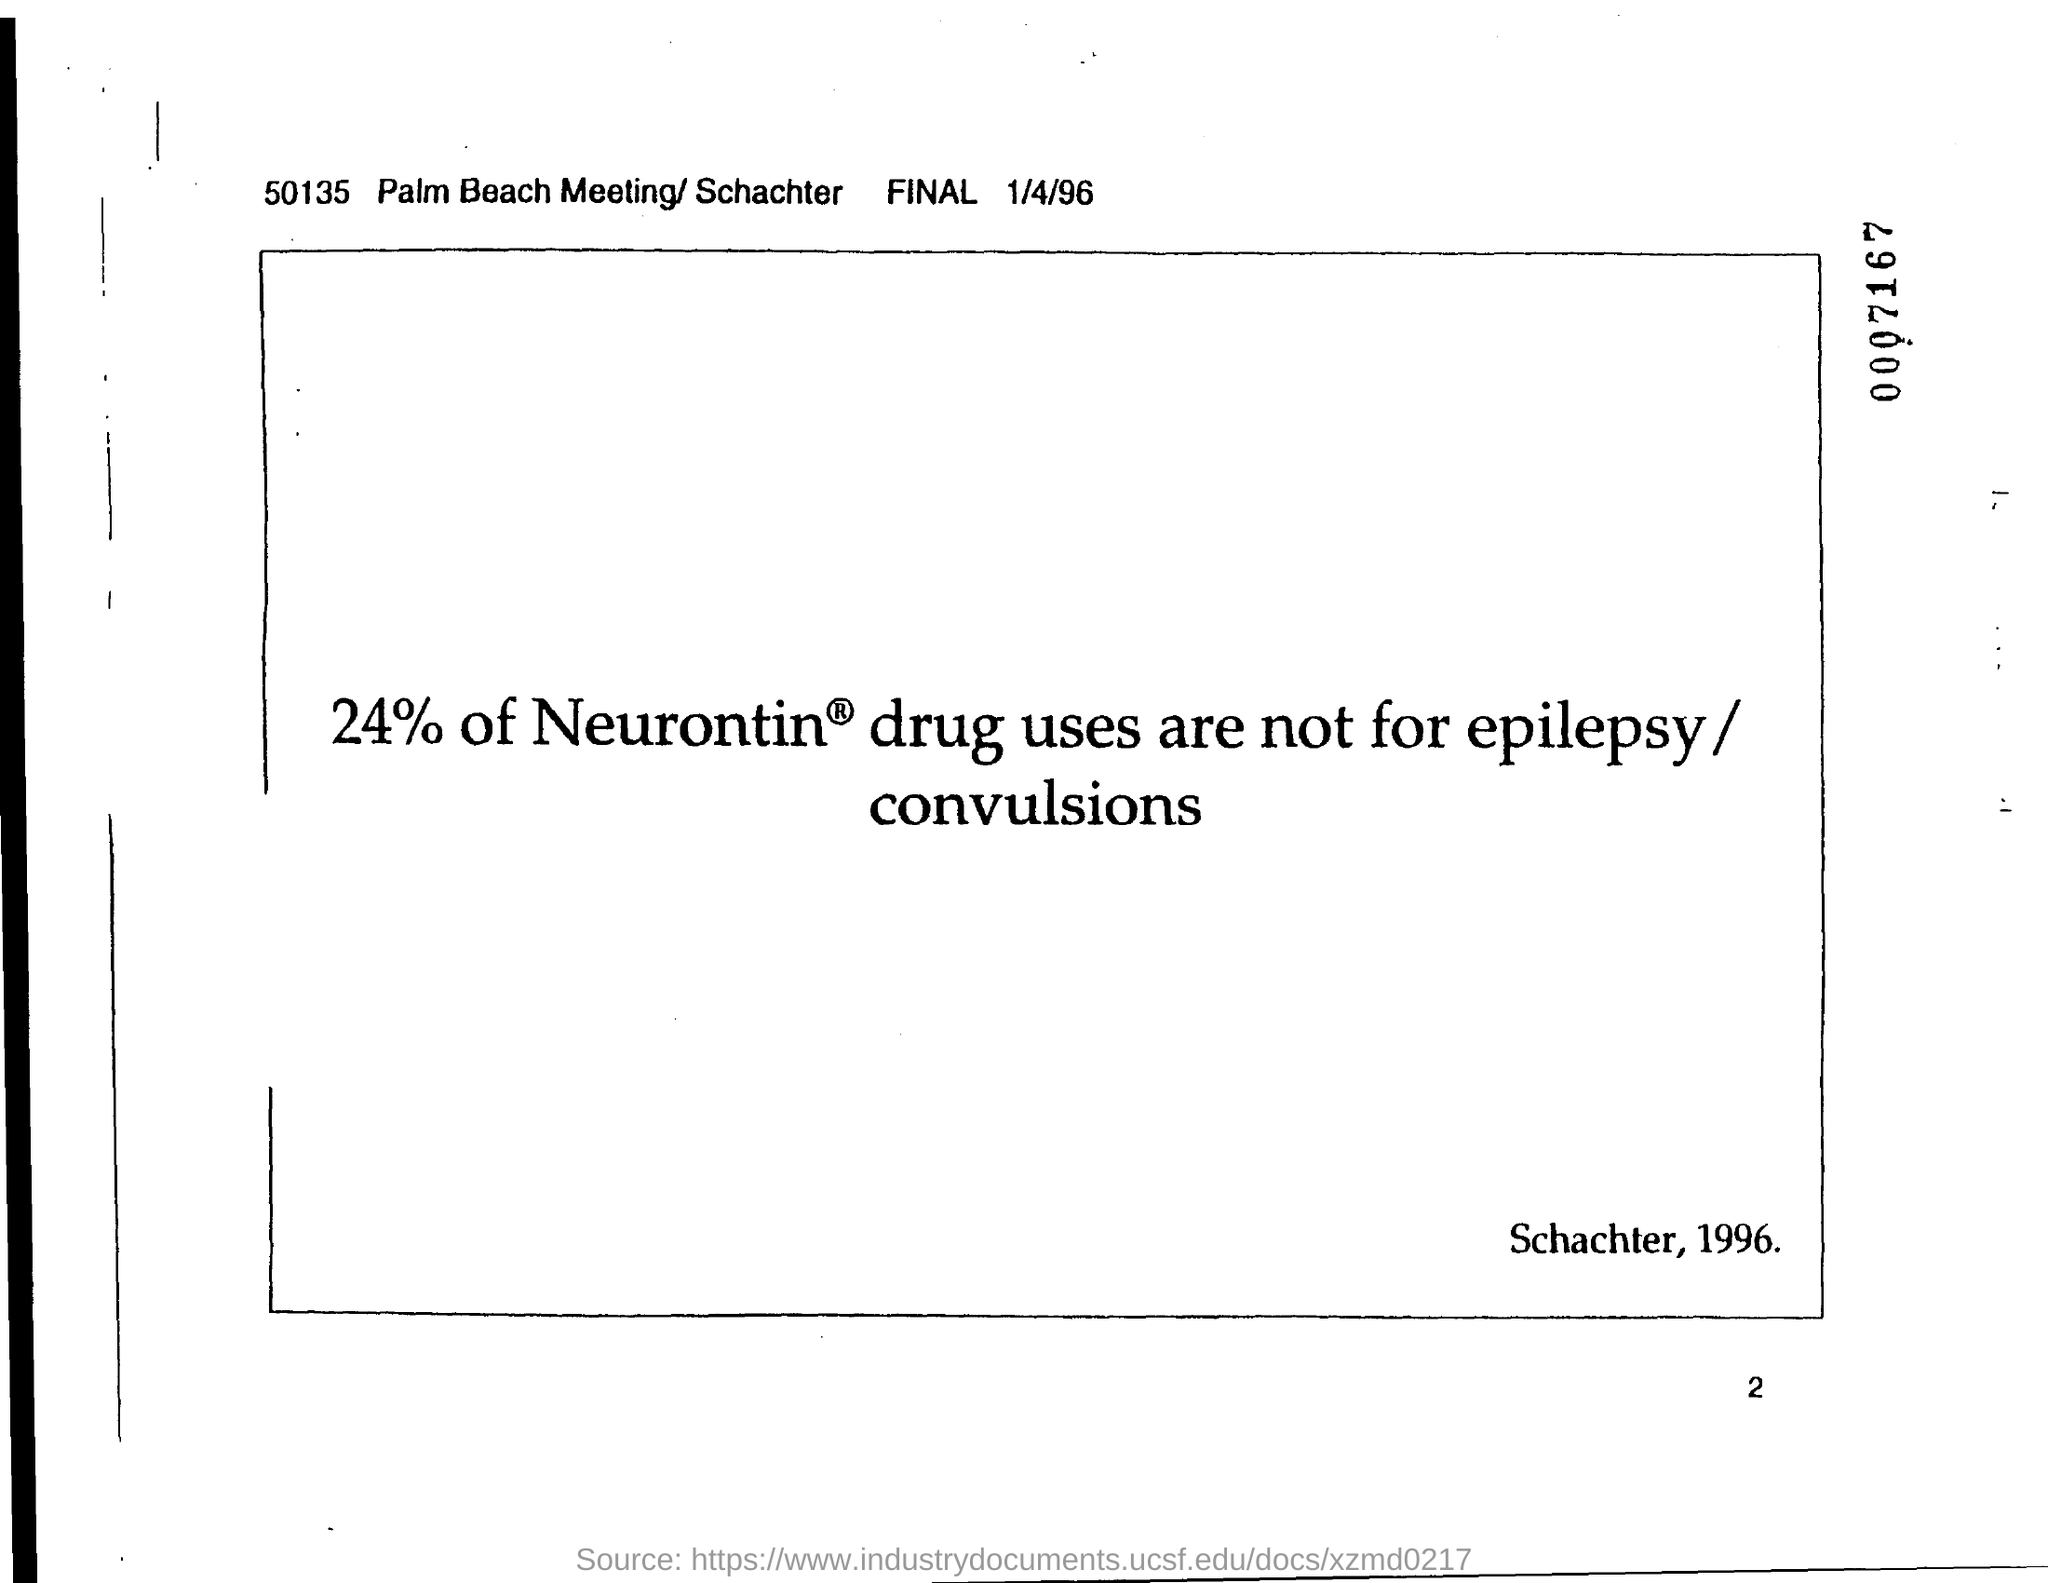Give some essential details in this illustration. The date is January 4th, 1996. 